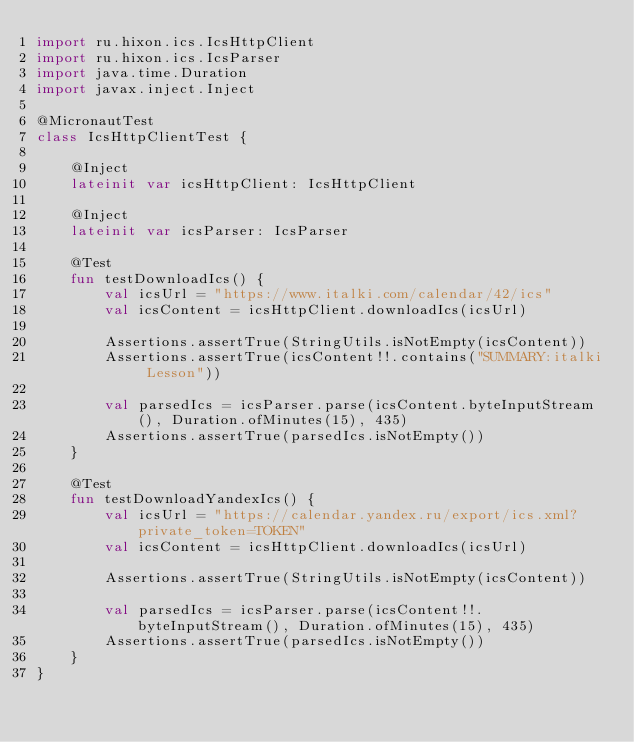Convert code to text. <code><loc_0><loc_0><loc_500><loc_500><_Kotlin_>import ru.hixon.ics.IcsHttpClient
import ru.hixon.ics.IcsParser
import java.time.Duration
import javax.inject.Inject

@MicronautTest
class IcsHttpClientTest {

    @Inject
    lateinit var icsHttpClient: IcsHttpClient

    @Inject
    lateinit var icsParser: IcsParser

    @Test
    fun testDownloadIcs() {
        val icsUrl = "https://www.italki.com/calendar/42/ics"
        val icsContent = icsHttpClient.downloadIcs(icsUrl)

        Assertions.assertTrue(StringUtils.isNotEmpty(icsContent))
        Assertions.assertTrue(icsContent!!.contains("SUMMARY:italki Lesson"))

        val parsedIcs = icsParser.parse(icsContent.byteInputStream(), Duration.ofMinutes(15), 435)
        Assertions.assertTrue(parsedIcs.isNotEmpty())
    }

    @Test
    fun testDownloadYandexIcs() {
        val icsUrl = "https://calendar.yandex.ru/export/ics.xml?private_token=TOKEN"
        val icsContent = icsHttpClient.downloadIcs(icsUrl)

        Assertions.assertTrue(StringUtils.isNotEmpty(icsContent))

        val parsedIcs = icsParser.parse(icsContent!!.byteInputStream(), Duration.ofMinutes(15), 435)
        Assertions.assertTrue(parsedIcs.isNotEmpty())
    }
}
</code> 